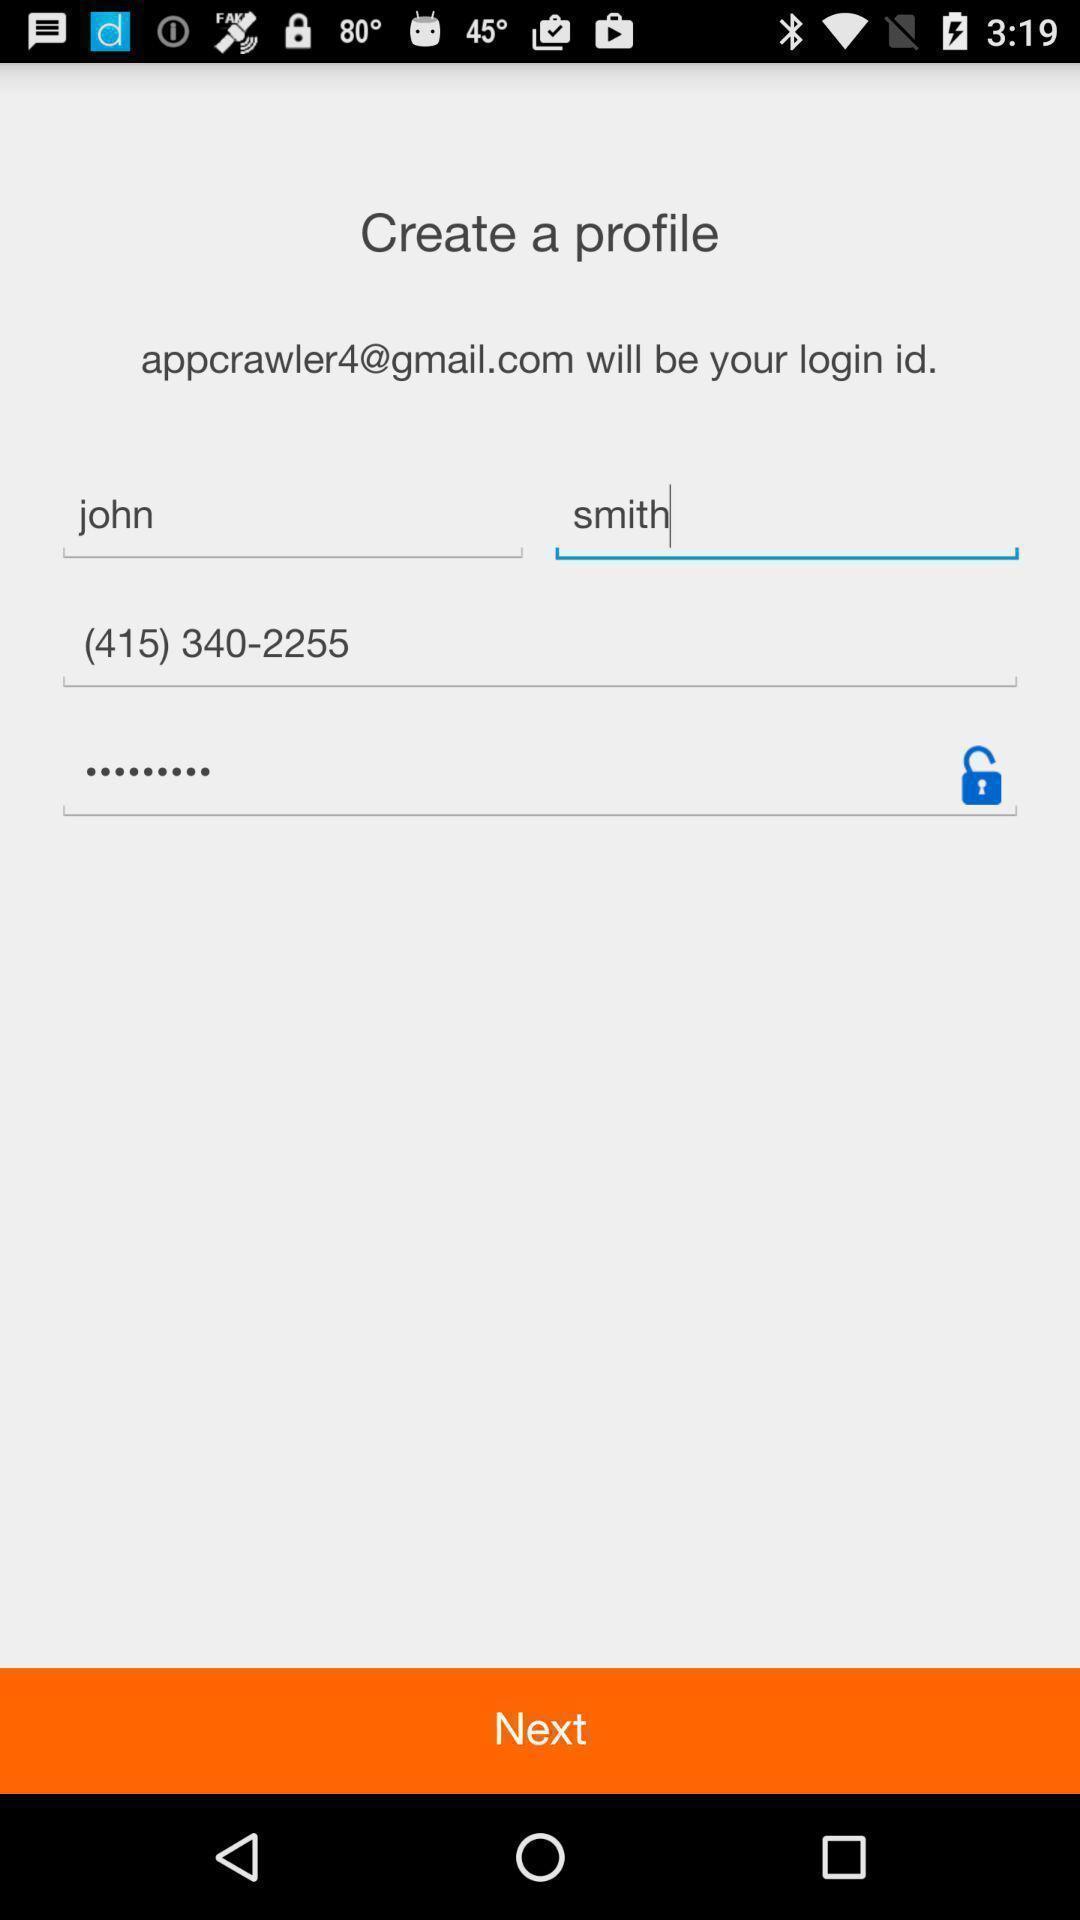What is the overall content of this screenshot? Profile page for creating an account. 